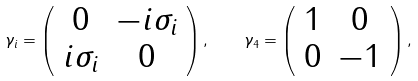Convert formula to latex. <formula><loc_0><loc_0><loc_500><loc_500>\gamma _ { i } = \left ( \begin{array} { c c } 0 & - i \sigma _ { i } \\ i \sigma _ { i } & 0 \end{array} \right ) , \quad \gamma _ { 4 } = \left ( \begin{array} { c c } 1 & 0 \\ 0 & - 1 \end{array} \right ) ,</formula> 